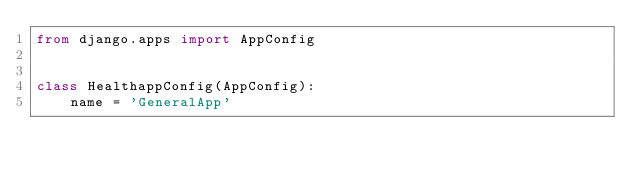<code> <loc_0><loc_0><loc_500><loc_500><_Python_>from django.apps import AppConfig


class HealthappConfig(AppConfig):
    name = 'GeneralApp'
</code> 